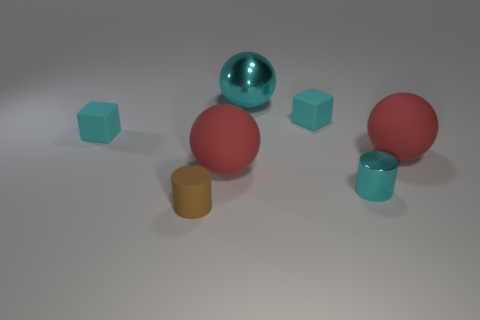Subtract all large red balls. How many balls are left? 1 Subtract all cyan cubes. How many red balls are left? 2 Add 3 cyan metal things. How many objects exist? 10 Subtract all red spheres. How many spheres are left? 1 Subtract 2 spheres. How many spheres are left? 1 Subtract all brown cubes. Subtract all blue balls. How many cubes are left? 2 Subtract all small cyan metal cylinders. Subtract all small brown matte things. How many objects are left? 5 Add 2 tiny metallic things. How many tiny metallic things are left? 3 Add 1 rubber cubes. How many rubber cubes exist? 3 Subtract 0 blue balls. How many objects are left? 7 